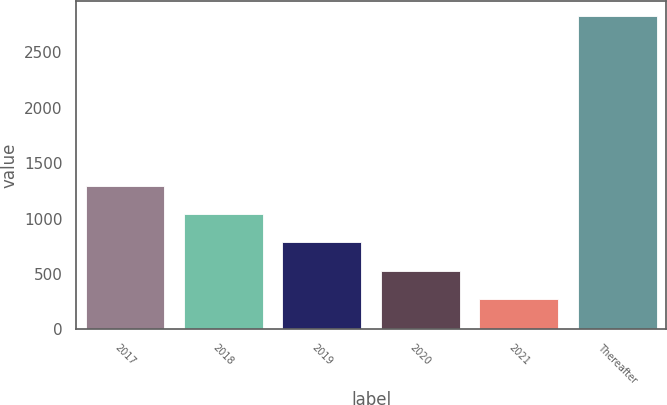Convert chart. <chart><loc_0><loc_0><loc_500><loc_500><bar_chart><fcel>2017<fcel>2018<fcel>2019<fcel>2020<fcel>2021<fcel>Thereafter<nl><fcel>1296.38<fcel>1041.31<fcel>786.24<fcel>531.17<fcel>276.1<fcel>2826.8<nl></chart> 